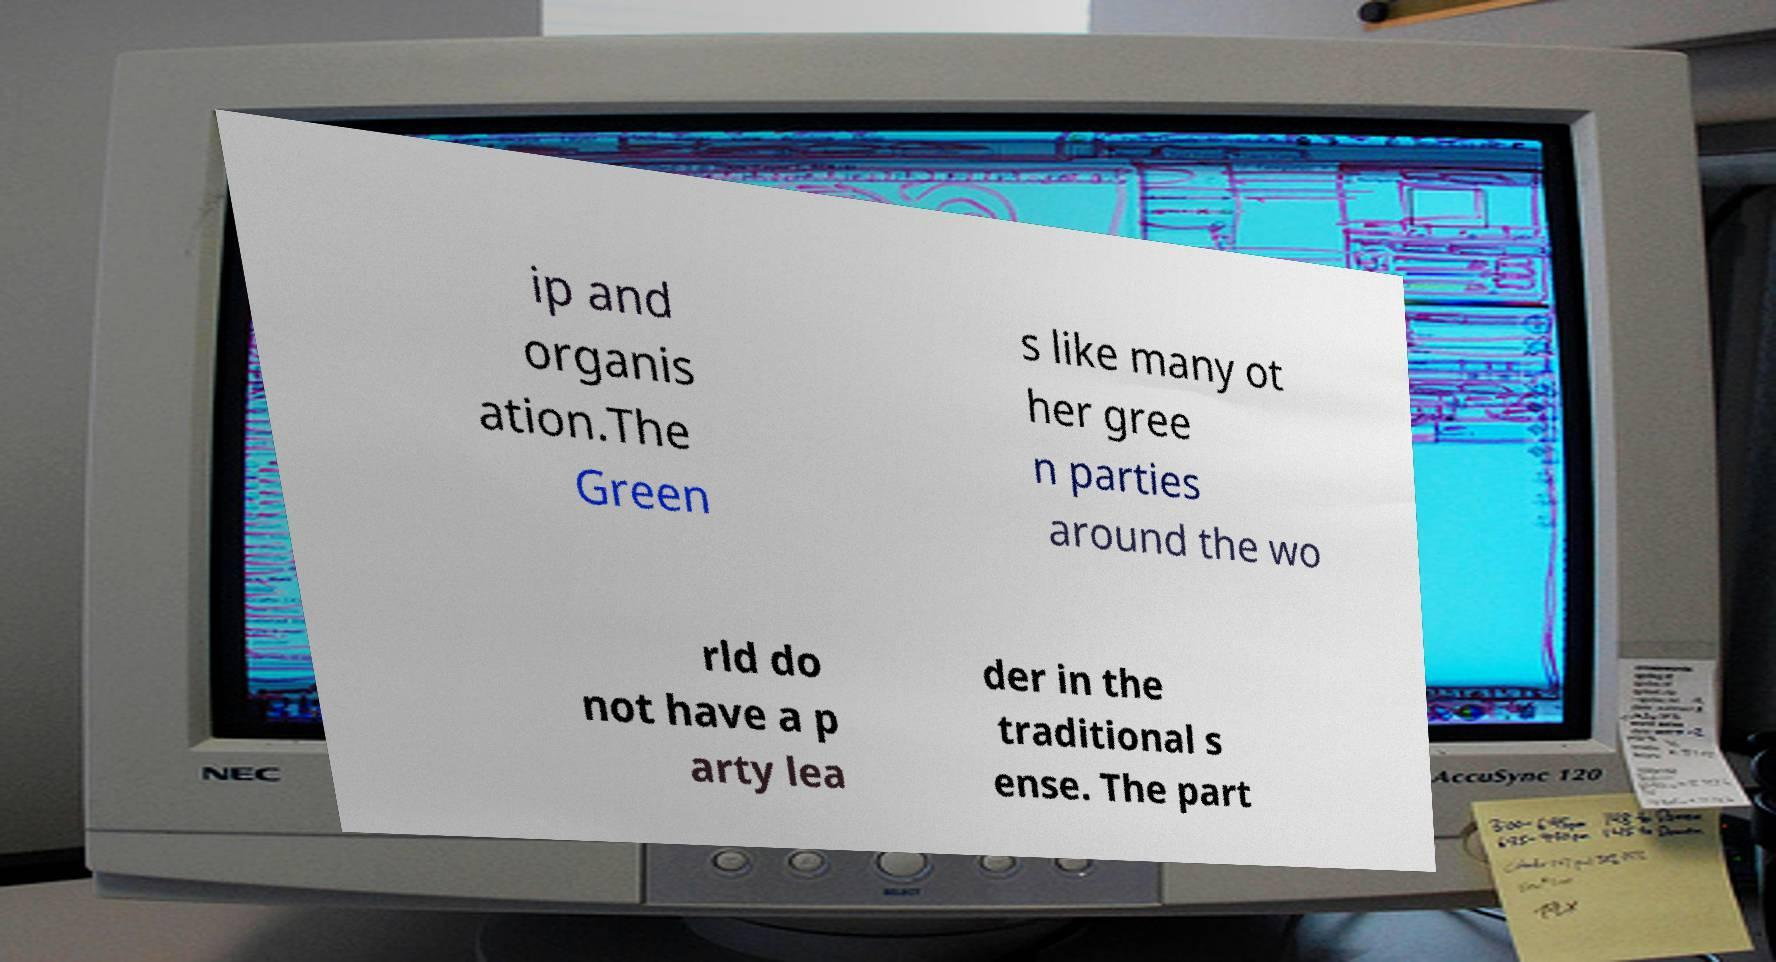Please read and relay the text visible in this image. What does it say? ip and organis ation.The Green s like many ot her gree n parties around the wo rld do not have a p arty lea der in the traditional s ense. The part 